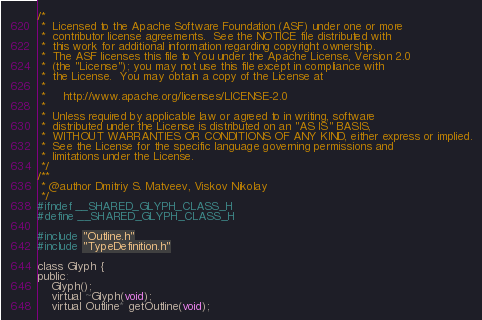Convert code to text. <code><loc_0><loc_0><loc_500><loc_500><_C_>/*
 *  Licensed to the Apache Software Foundation (ASF) under one or more
 *  contributor license agreements.  See the NOTICE file distributed with
 *  this work for additional information regarding copyright ownership.
 *  The ASF licenses this file to You under the Apache License, Version 2.0
 *  (the "License"); you may not use this file except in compliance with
 *  the License.  You may obtain a copy of the License at
 *
 *     http://www.apache.org/licenses/LICENSE-2.0
 *
 *  Unless required by applicable law or agreed to in writing, software
 *  distributed under the License is distributed on an "AS IS" BASIS,
 *  WITHOUT WARRANTIES OR CONDITIONS OF ANY KIND, either express or implied.
 *  See the License for the specific language governing permissions and
 *  limitations under the License.
 */
/**
 * @author Dmitriy S. Matveev, Viskov Nikolay 
 */
#ifndef __SHARED_GLYPH_CLASS_H
#define __SHARED_GLYPH_CLASS_H

#include "Outline.h"
#include "TypeDefinition.h"

class Glyph {
public:
	Glyph();
	virtual ~Glyph(void);
	virtual Outline* getOutline(void);</code> 